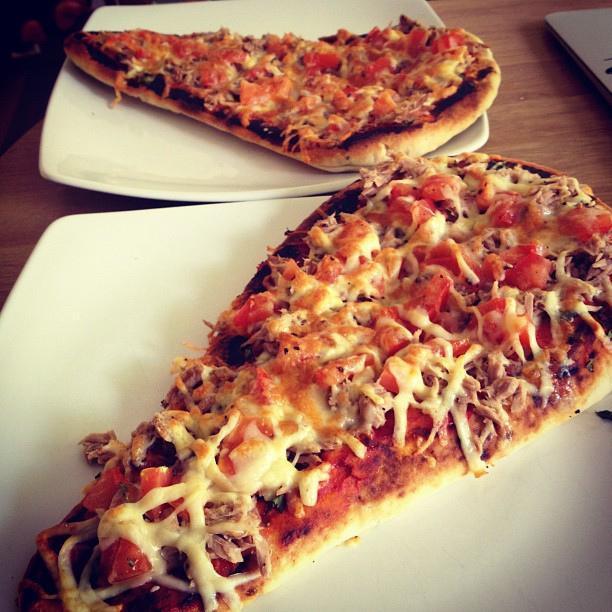How many pizzas can be seen?
Give a very brief answer. 2. 